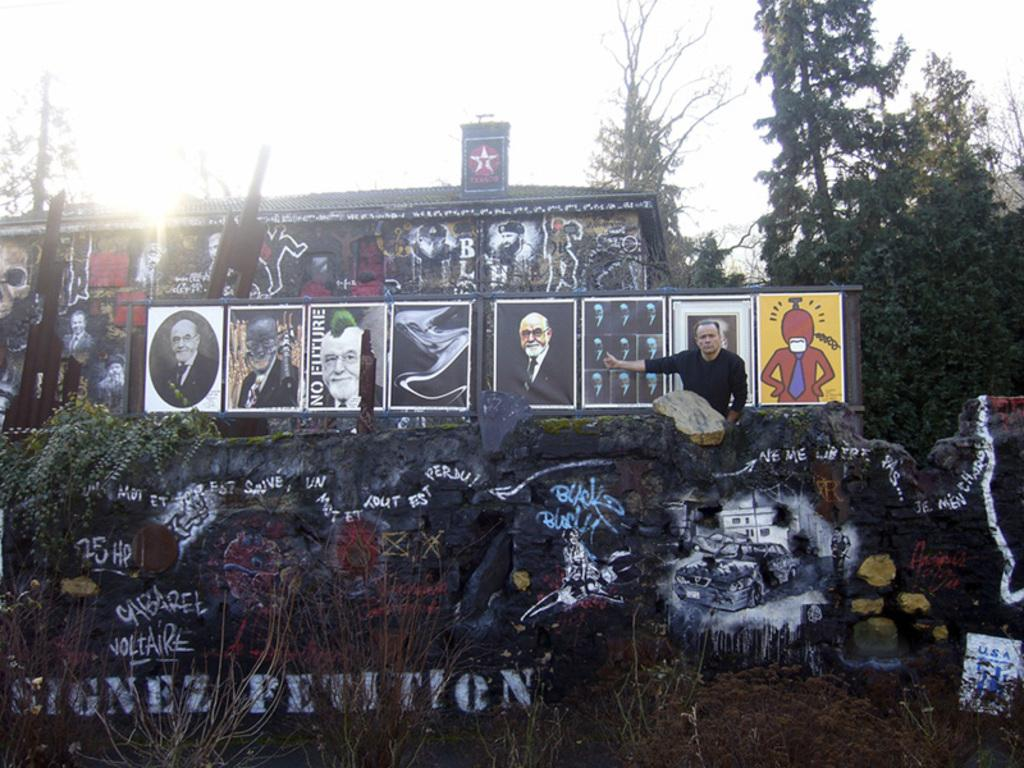What type of vegetation is present in the image? There is grass in the image. What can be seen on the wall in the image? There is a painting on the wall in the image. Can you describe the person in the image? There is a person in the image. What is the object containing photos called? The object containing photos is an album or photo frame. What other natural elements are present in the image? There are trees in the image. What is visible in the background of the image? There is a sky visible in the image. What type of store is depicted in the painting on the wall? There is no store depicted in the painting on the wall; it is a painting, not a photograph or representation of a store. What type of insurance policy does the person in the image have? There is no information about the person's insurance policy in the image. 